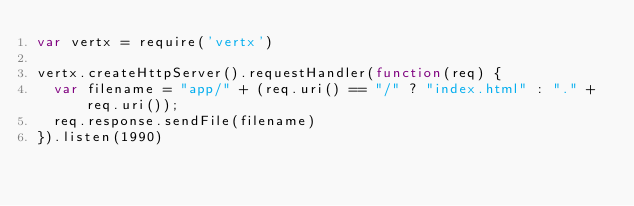<code> <loc_0><loc_0><loc_500><loc_500><_JavaScript_>var vertx = require('vertx')

vertx.createHttpServer().requestHandler(function(req) {
  var filename = "app/" + (req.uri() == "/" ? "index.html" : "." + req.uri());
  req.response.sendFile(filename)
}).listen(1990)</code> 